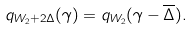<formula> <loc_0><loc_0><loc_500><loc_500>q _ { W _ { 2 } + 2 \Delta } ( \gamma ) = q _ { W _ { 2 } } ( \gamma - \overline { \Delta } ) .</formula> 